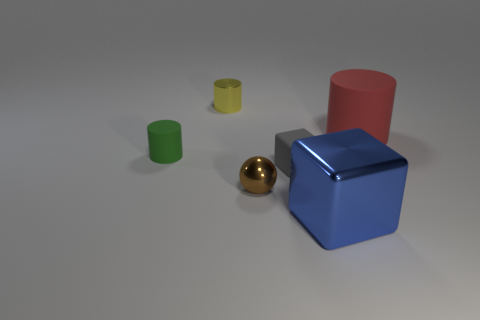Imagine this is a scene from a story. What thematic elements could these objects represent? These objects could represent various thematic elements such as diversity and uniqueness, with their different shapes and colors standing for individuality. The arrangement might symbolize balance and harmony among different entities. 